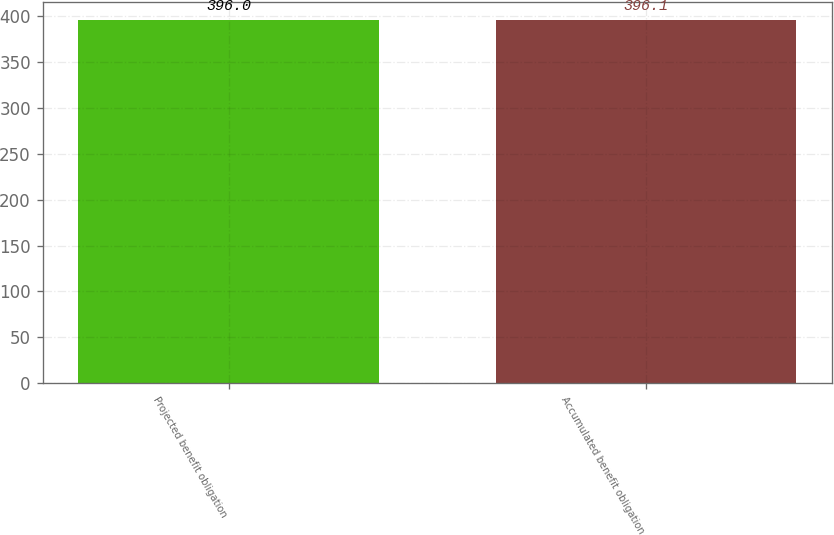<chart> <loc_0><loc_0><loc_500><loc_500><bar_chart><fcel>Projected benefit obligation<fcel>Accumulated benefit obligation<nl><fcel>396<fcel>396.1<nl></chart> 